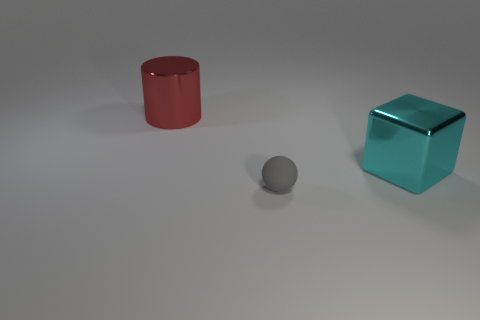There is a metal object behind the big shiny object to the right of the big red shiny thing; what color is it? The metal object situated behind the larger translucent teal cube, to the right of the red cylinder, is gray in color. 